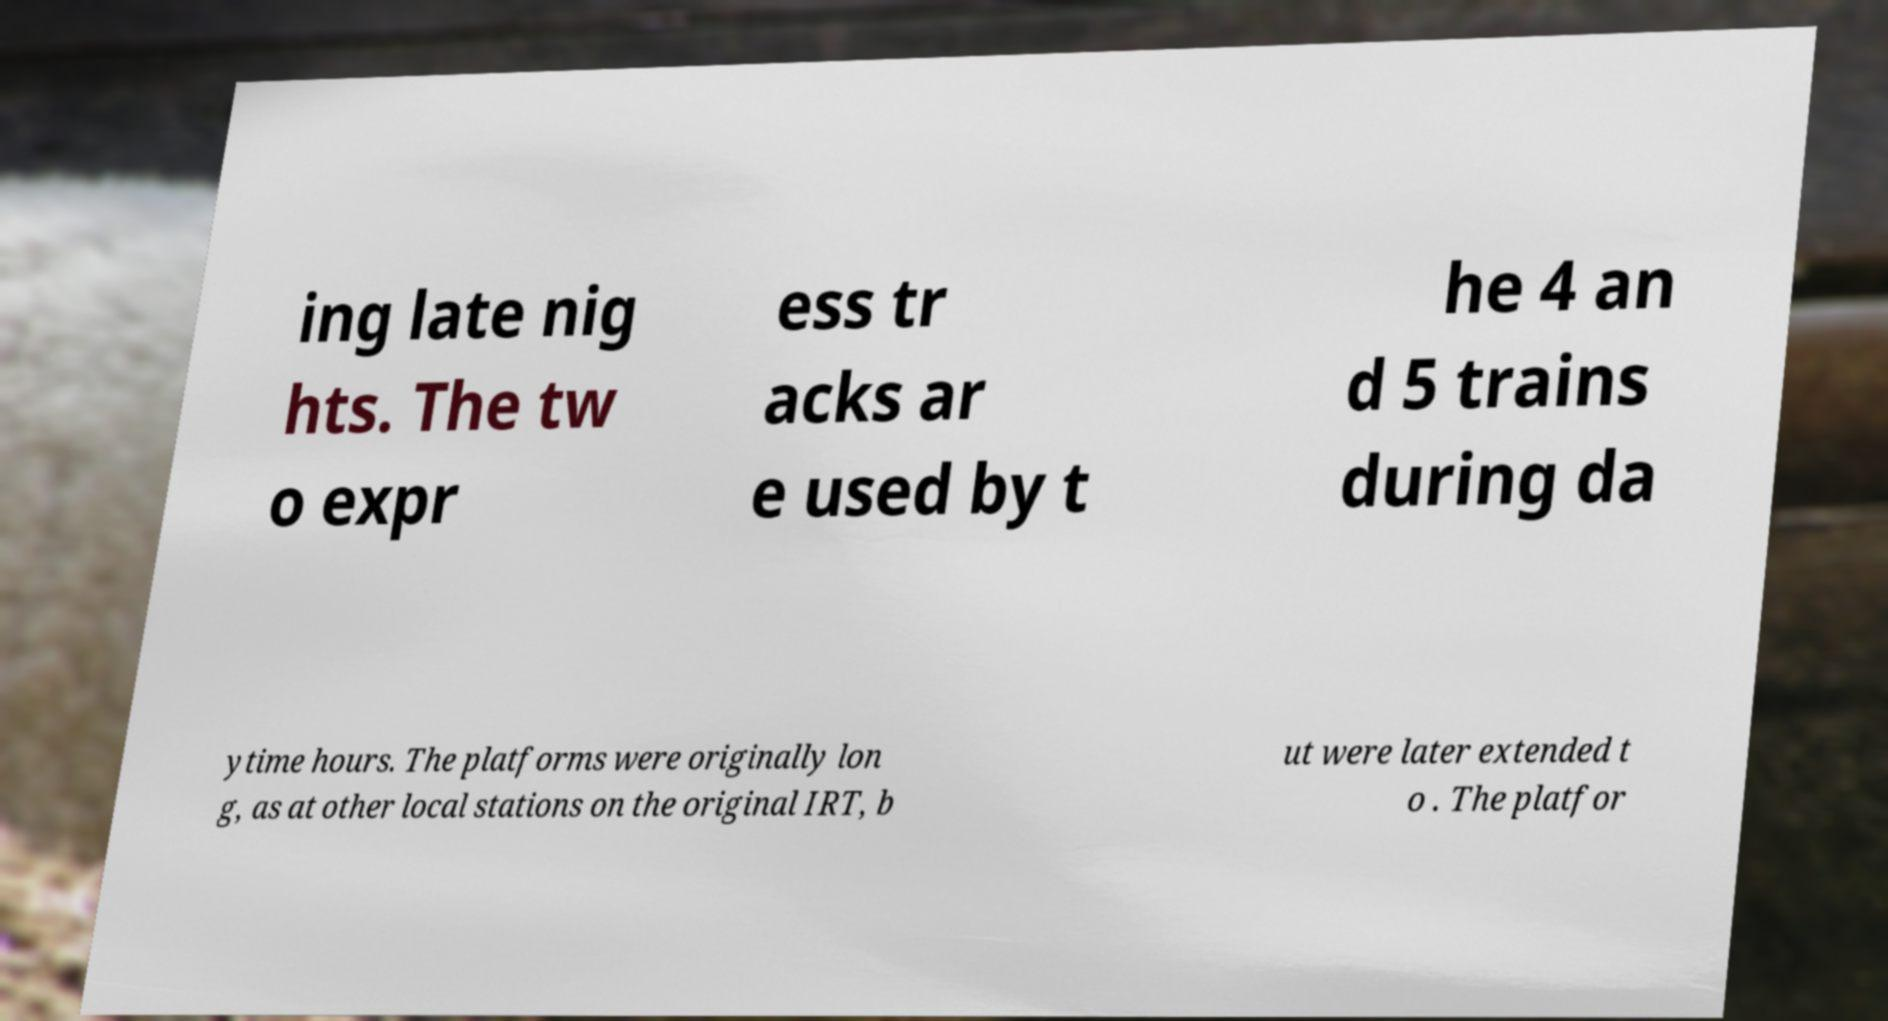Please read and relay the text visible in this image. What does it say? ing late nig hts. The tw o expr ess tr acks ar e used by t he 4 an d 5 trains during da ytime hours. The platforms were originally lon g, as at other local stations on the original IRT, b ut were later extended t o . The platfor 